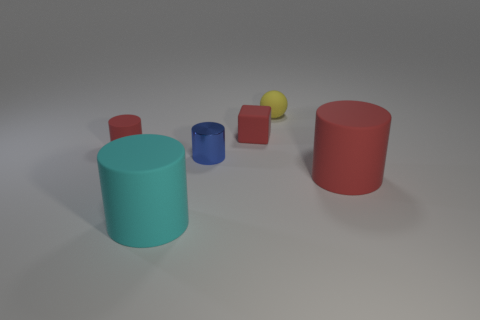Subtract all large red rubber cylinders. How many cylinders are left? 3 Add 2 tiny matte blocks. How many objects exist? 8 Subtract all red cylinders. How many cylinders are left? 2 Subtract all brown blocks. How many gray spheres are left? 0 Subtract all large cyan metallic things. Subtract all red things. How many objects are left? 3 Add 5 red things. How many red things are left? 8 Add 3 large cylinders. How many large cylinders exist? 5 Subtract 0 cyan spheres. How many objects are left? 6 Subtract all spheres. How many objects are left? 5 Subtract all gray cylinders. Subtract all red blocks. How many cylinders are left? 4 